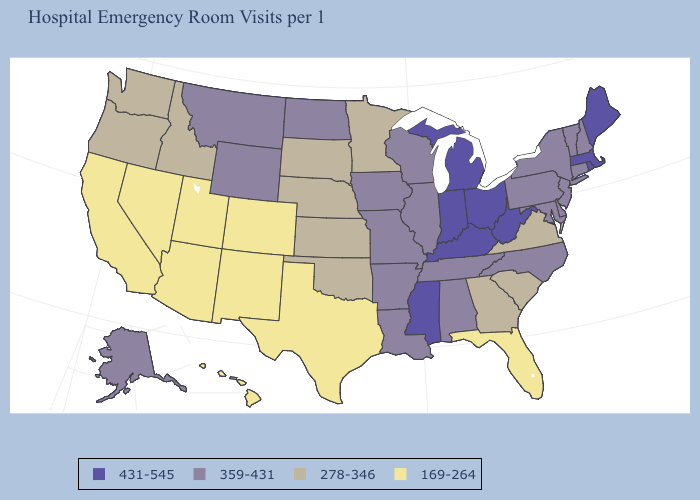What is the value of North Dakota?
Concise answer only. 359-431. What is the lowest value in the USA?
Write a very short answer. 169-264. What is the lowest value in the South?
Write a very short answer. 169-264. Is the legend a continuous bar?
Answer briefly. No. Name the states that have a value in the range 431-545?
Be succinct. Indiana, Kentucky, Maine, Massachusetts, Michigan, Mississippi, Ohio, Rhode Island, West Virginia. What is the value of Arizona?
Write a very short answer. 169-264. What is the highest value in the South ?
Be succinct. 431-545. Name the states that have a value in the range 431-545?
Be succinct. Indiana, Kentucky, Maine, Massachusetts, Michigan, Mississippi, Ohio, Rhode Island, West Virginia. What is the value of Kentucky?
Answer briefly. 431-545. Does the map have missing data?
Short answer required. No. Does California have the same value as North Carolina?
Answer briefly. No. Which states have the lowest value in the South?
Be succinct. Florida, Texas. What is the value of Massachusetts?
Give a very brief answer. 431-545. Name the states that have a value in the range 278-346?
Give a very brief answer. Georgia, Idaho, Kansas, Minnesota, Nebraska, Oklahoma, Oregon, South Carolina, South Dakota, Virginia, Washington. Name the states that have a value in the range 359-431?
Short answer required. Alabama, Alaska, Arkansas, Connecticut, Delaware, Illinois, Iowa, Louisiana, Maryland, Missouri, Montana, New Hampshire, New Jersey, New York, North Carolina, North Dakota, Pennsylvania, Tennessee, Vermont, Wisconsin, Wyoming. 